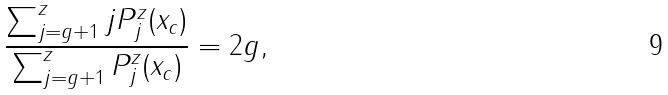Convert formula to latex. <formula><loc_0><loc_0><loc_500><loc_500>\frac { \sum _ { j = g + 1 } ^ { z } j P _ { j } ^ { z } ( x _ { c } ) } { \sum _ { j = g + 1 } ^ { z } P _ { j } ^ { z } ( x _ { c } ) } = 2 g ,</formula> 